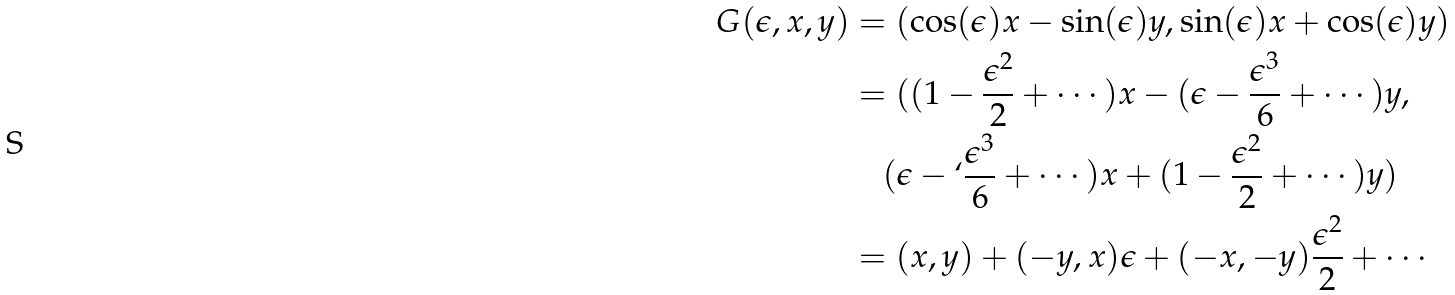<formula> <loc_0><loc_0><loc_500><loc_500>G ( \epsilon , x , y ) & = ( \cos ( \epsilon ) x - \sin ( \epsilon ) y , \sin ( \epsilon ) x + \cos ( \epsilon ) y ) \\ & = ( ( 1 - \frac { \epsilon ^ { 2 } } { 2 } + \cdots ) x - ( \epsilon - \frac { \epsilon ^ { 3 } } { 6 } + \cdots ) y , \\ & \quad ( \epsilon - ` \frac { \epsilon ^ { 3 } } { 6 } + \cdots ) x + ( 1 - \frac { \epsilon ^ { 2 } } { 2 } + \cdots ) y ) \\ & = ( x , y ) + ( - y , x ) \epsilon + ( - x , - y ) \frac { \epsilon ^ { 2 } } { 2 } + \cdots</formula> 